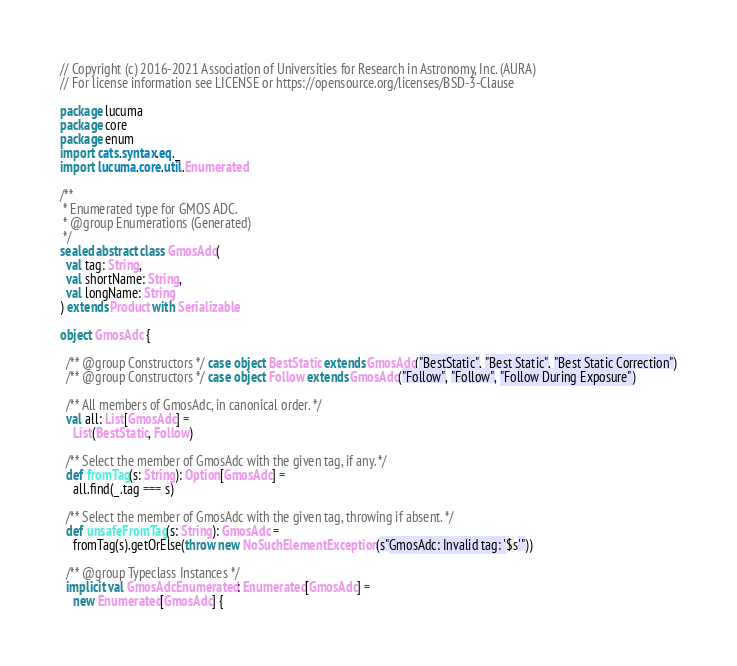Convert code to text. <code><loc_0><loc_0><loc_500><loc_500><_Scala_>// Copyright (c) 2016-2021 Association of Universities for Research in Astronomy, Inc. (AURA)
// For license information see LICENSE or https://opensource.org/licenses/BSD-3-Clause

package lucuma
package core
package enum
import cats.syntax.eq._
import lucuma.core.util.Enumerated

/**
 * Enumerated type for GMOS ADC.
 * @group Enumerations (Generated)
 */
sealed abstract class GmosAdc(
  val tag: String,
  val shortName: String,
  val longName: String
) extends Product with Serializable

object GmosAdc {

  /** @group Constructors */ case object BestStatic extends GmosAdc("BestStatic", "Best Static", "Best Static Correction")
  /** @group Constructors */ case object Follow extends GmosAdc("Follow", "Follow", "Follow During Exposure")

  /** All members of GmosAdc, in canonical order. */
  val all: List[GmosAdc] =
    List(BestStatic, Follow)

  /** Select the member of GmosAdc with the given tag, if any. */
  def fromTag(s: String): Option[GmosAdc] =
    all.find(_.tag === s)

  /** Select the member of GmosAdc with the given tag, throwing if absent. */
  def unsafeFromTag(s: String): GmosAdc =
    fromTag(s).getOrElse(throw new NoSuchElementException(s"GmosAdc: Invalid tag: '$s'"))

  /** @group Typeclass Instances */
  implicit val GmosAdcEnumerated: Enumerated[GmosAdc] =
    new Enumerated[GmosAdc] {</code> 